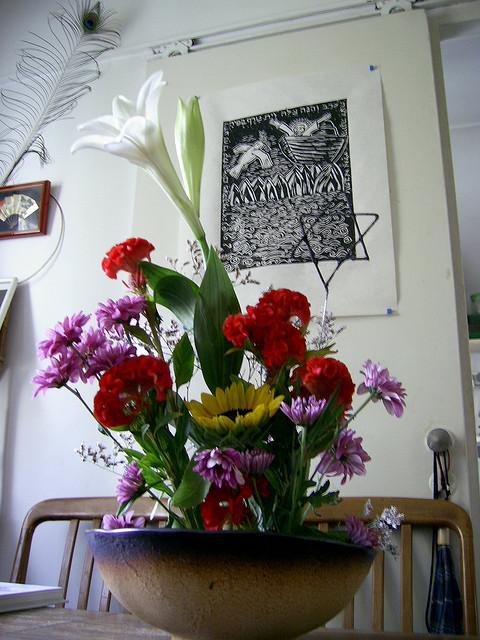What are these flowers in?
Quick response, please. Bowl. What flowers are at the top?
Write a very short answer. Lily. How many red flowers in the pot?
Be succinct. 6. 